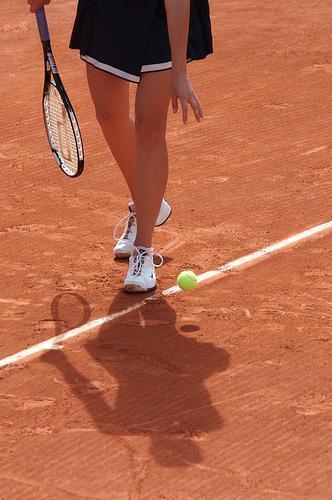How many players are in the photo?
Give a very brief answer. 1. 